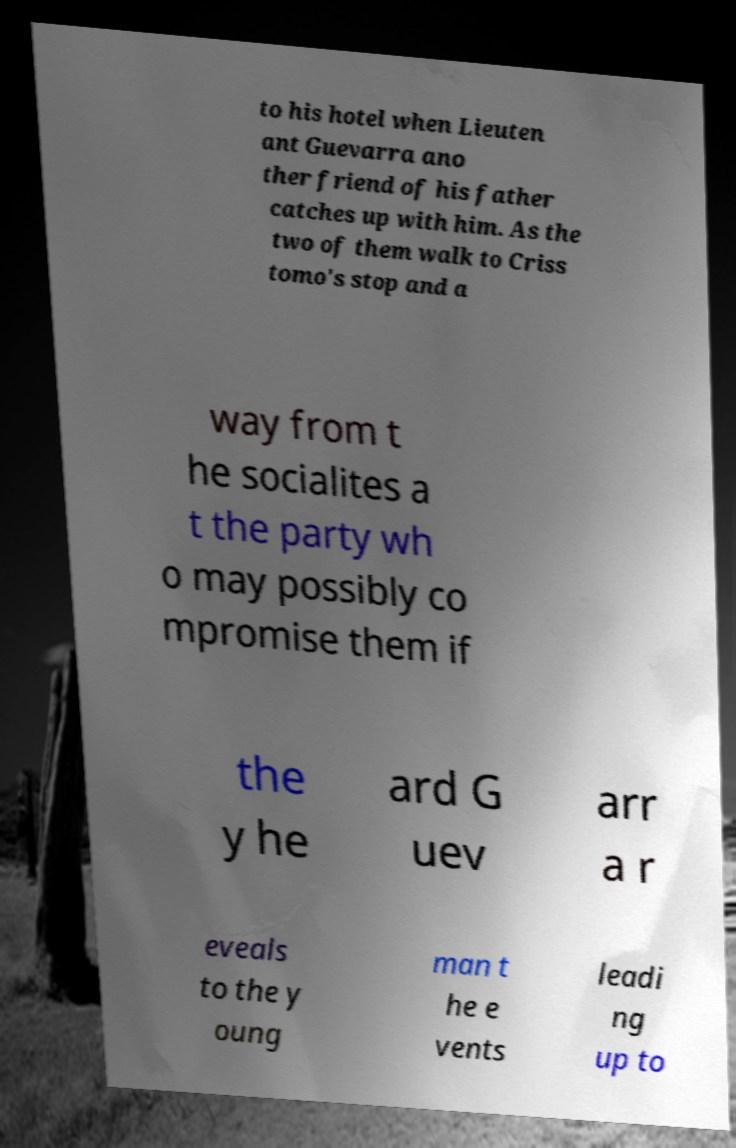There's text embedded in this image that I need extracted. Can you transcribe it verbatim? to his hotel when Lieuten ant Guevarra ano ther friend of his father catches up with him. As the two of them walk to Criss tomo's stop and a way from t he socialites a t the party wh o may possibly co mpromise them if the y he ard G uev arr a r eveals to the y oung man t he e vents leadi ng up to 